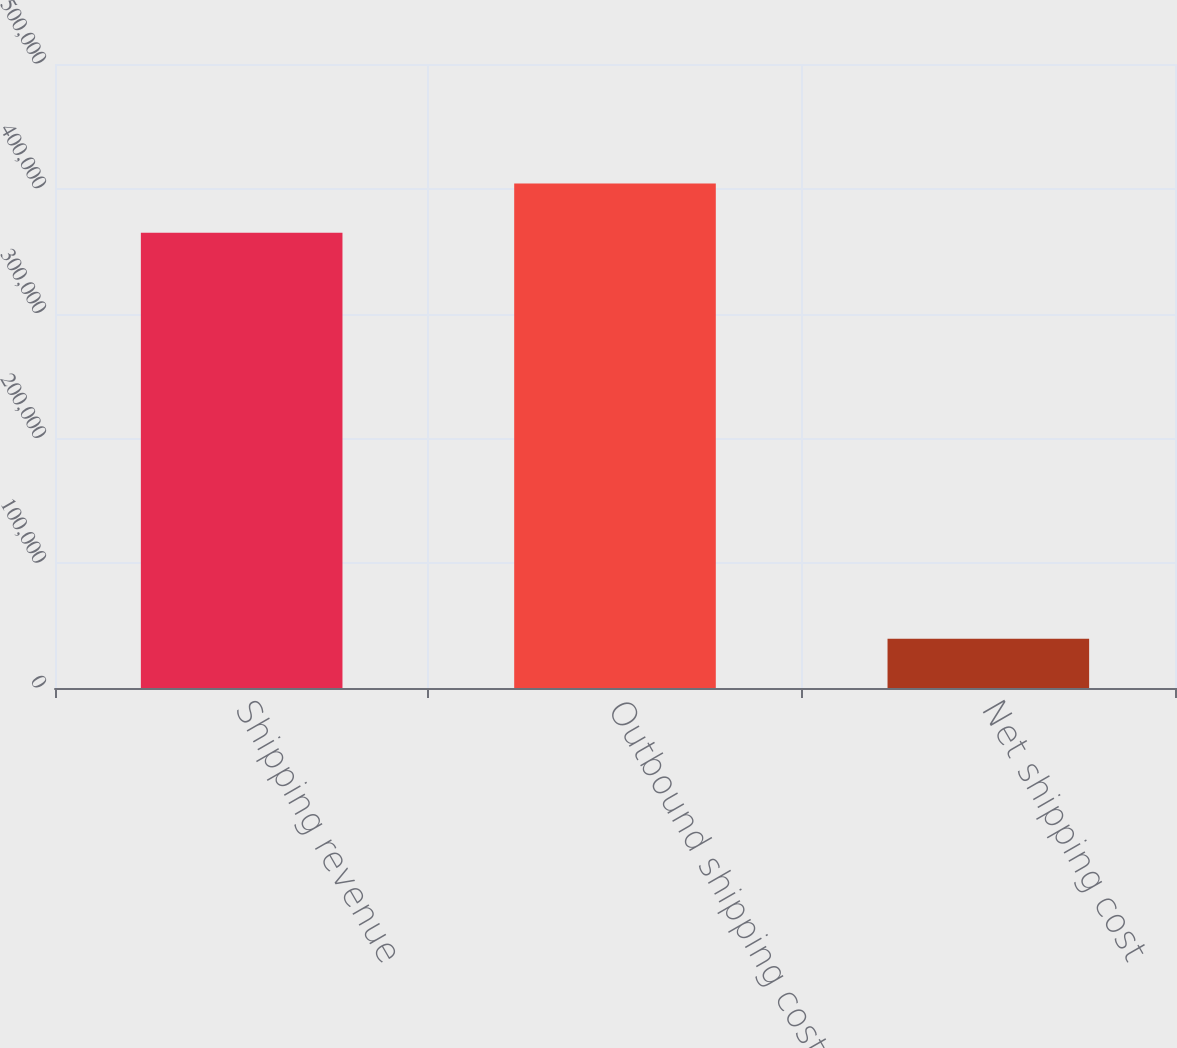Convert chart. <chart><loc_0><loc_0><loc_500><loc_500><bar_chart><fcel>Shipping revenue<fcel>Outbound shipping costs<fcel>Net shipping cost<nl><fcel>364749<fcel>404303<fcel>39554<nl></chart> 